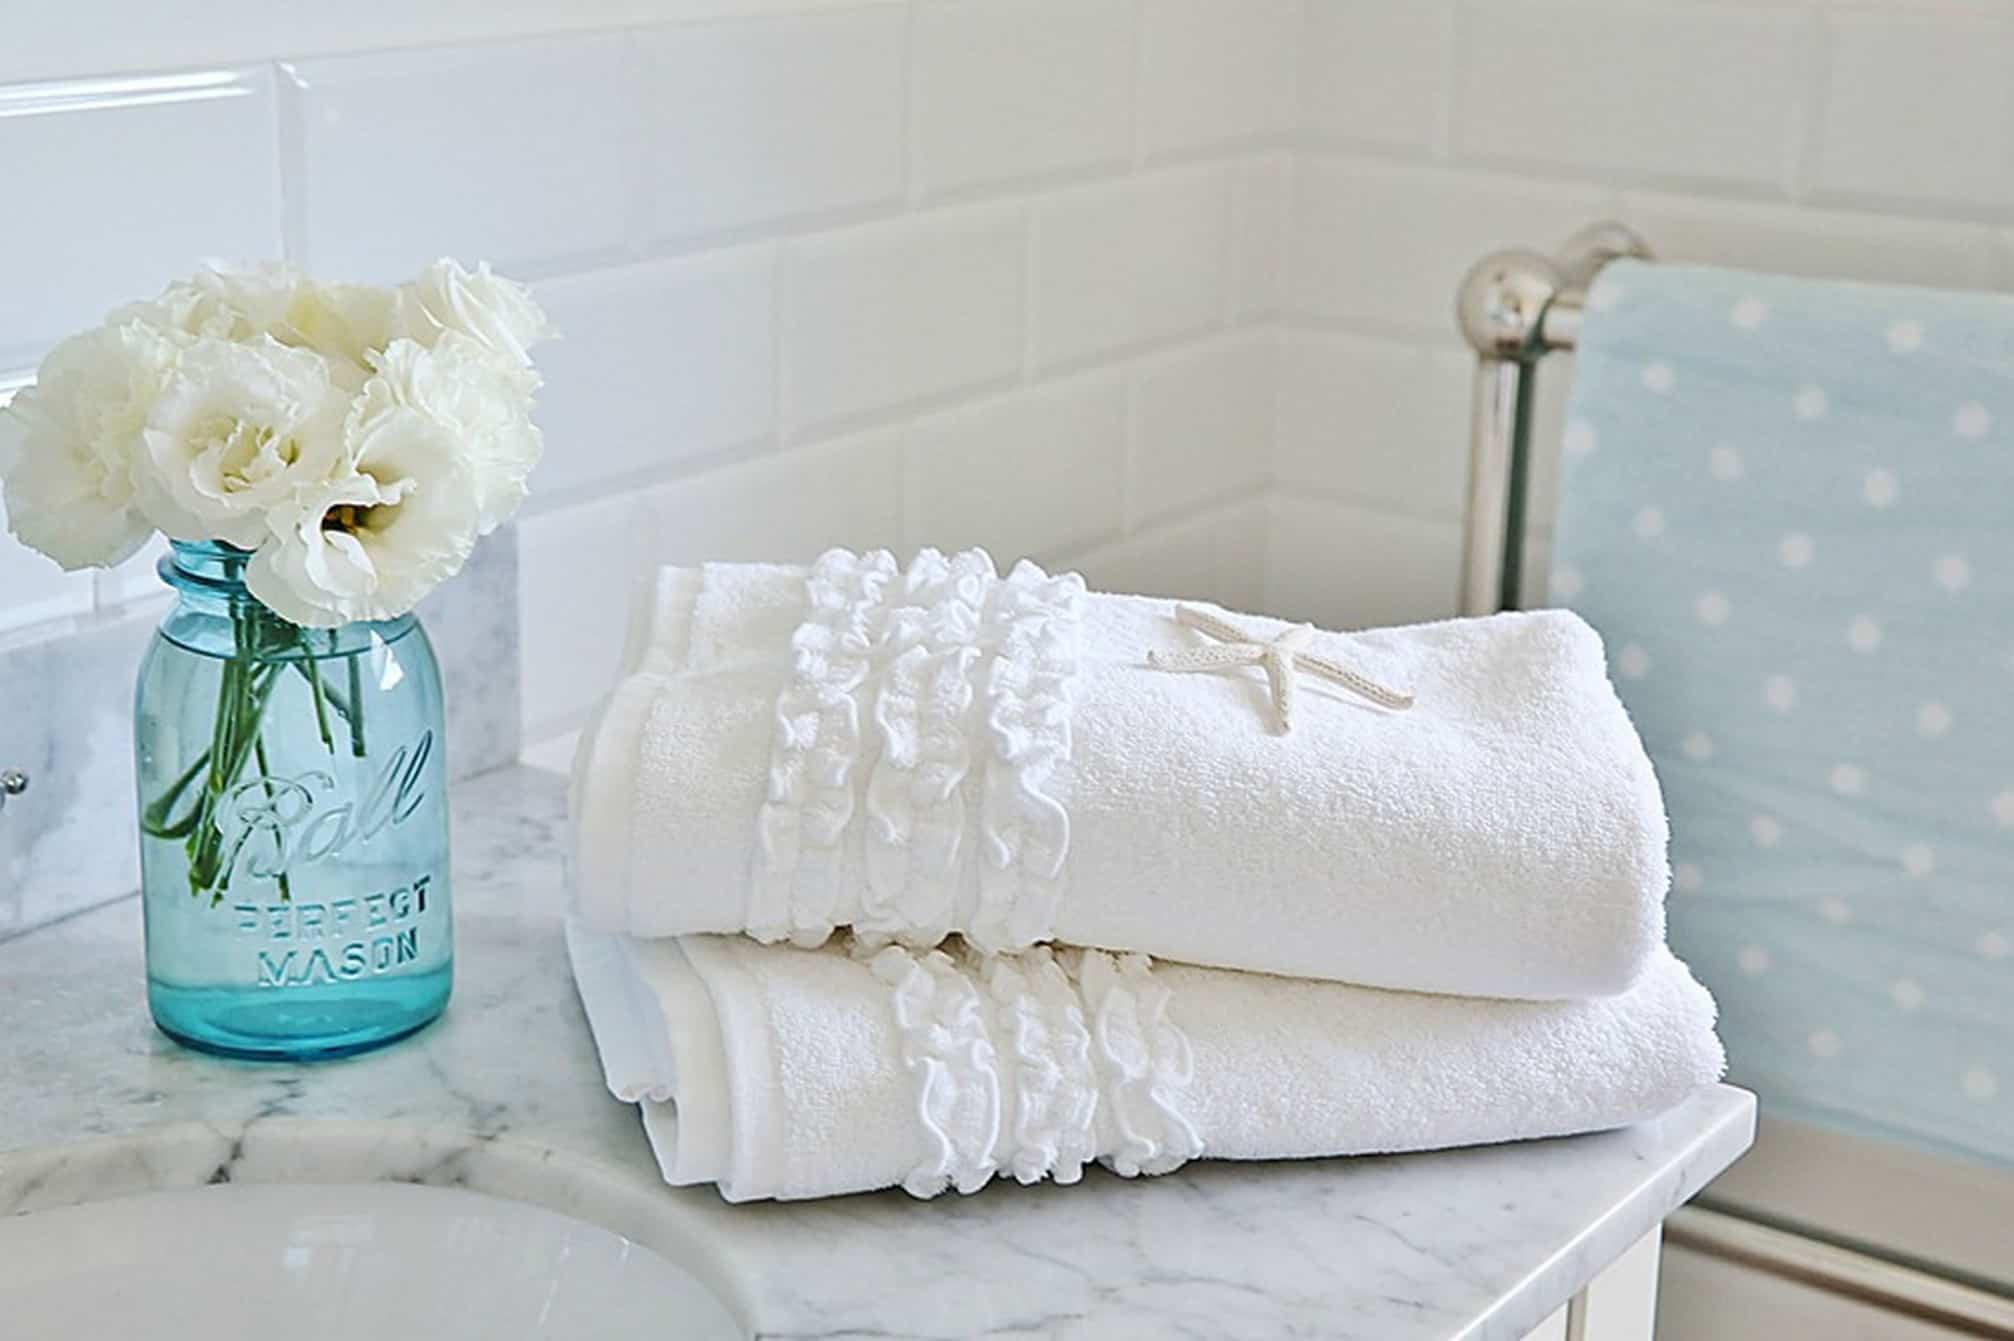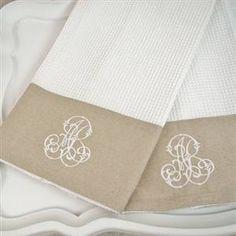The first image is the image on the left, the second image is the image on the right. For the images displayed, is the sentence "Each image shows lettered towels draped near a faucet." factually correct? Answer yes or no. No. 